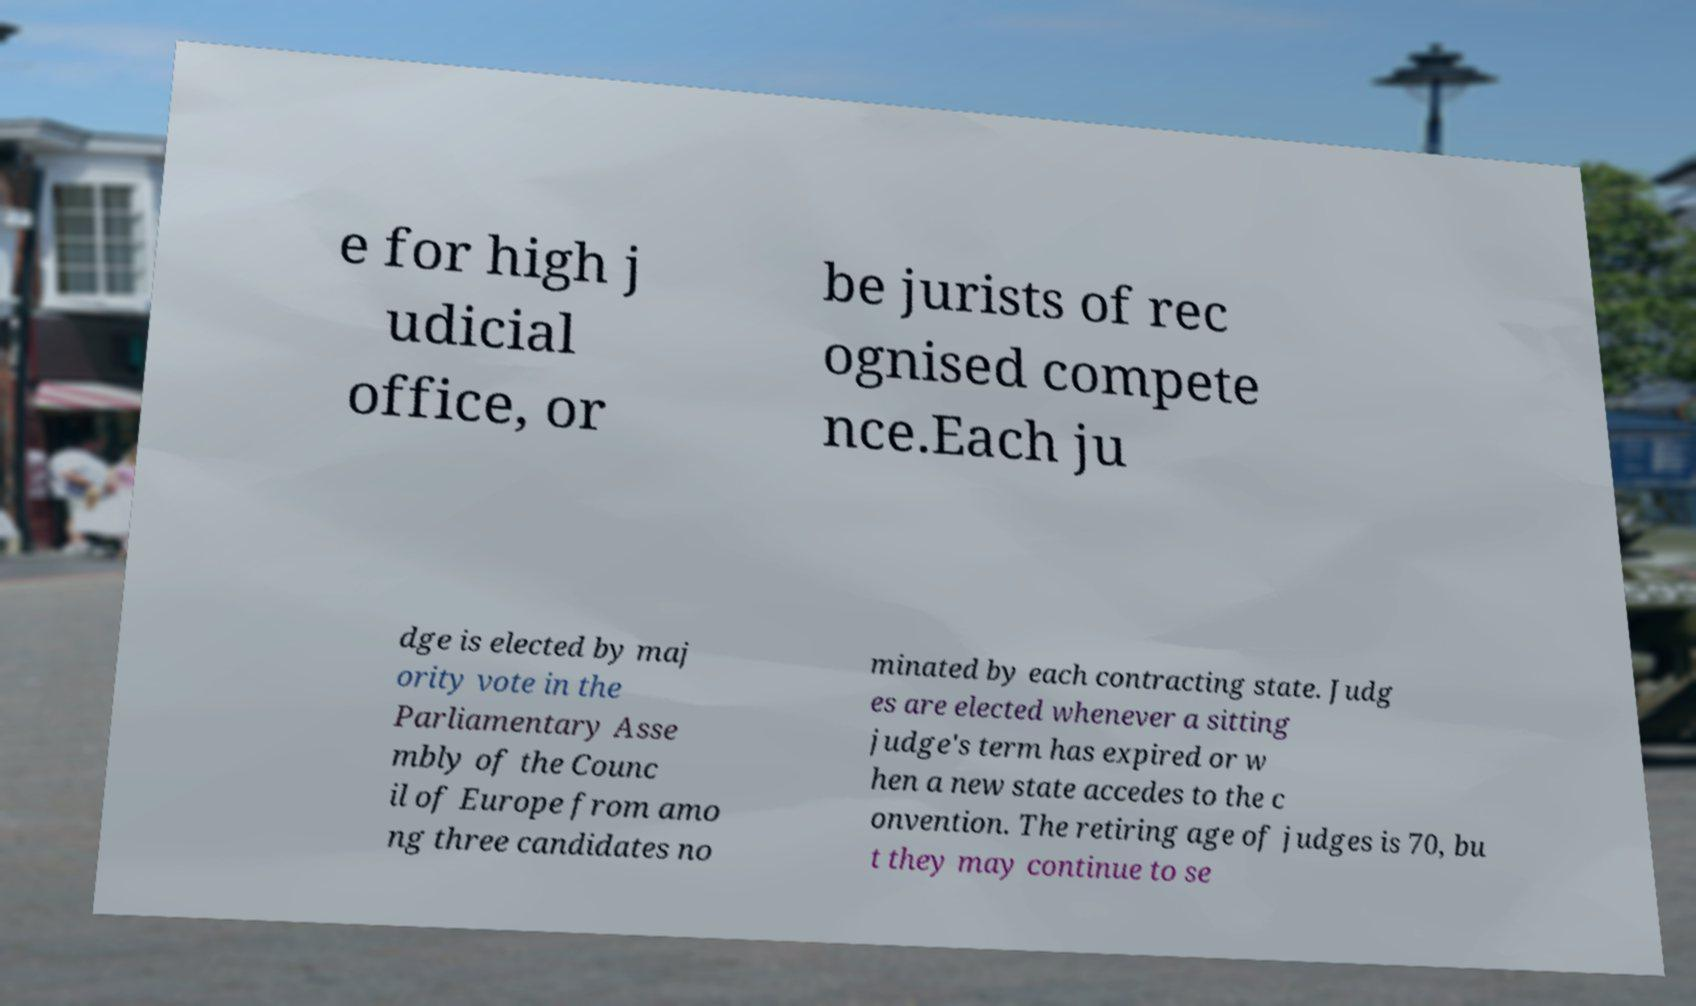Can you accurately transcribe the text from the provided image for me? e for high j udicial office, or be jurists of rec ognised compete nce.Each ju dge is elected by maj ority vote in the Parliamentary Asse mbly of the Counc il of Europe from amo ng three candidates no minated by each contracting state. Judg es are elected whenever a sitting judge's term has expired or w hen a new state accedes to the c onvention. The retiring age of judges is 70, bu t they may continue to se 